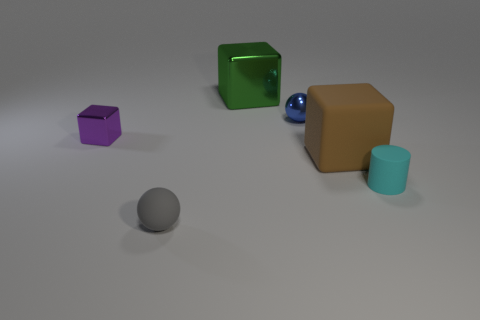Add 2 large gray matte objects. How many objects exist? 8 Subtract all spheres. How many objects are left? 4 Subtract 1 gray balls. How many objects are left? 5 Subtract all large brown metallic cylinders. Subtract all matte cylinders. How many objects are left? 5 Add 5 cyan objects. How many cyan objects are left? 6 Add 4 small blue objects. How many small blue objects exist? 5 